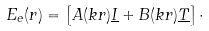Convert formula to latex. <formula><loc_0><loc_0><loc_500><loc_500>E _ { e } ( r ) = \left [ A ( k r ) \underline { I } + B ( k r ) \underline { T } \right ] \cdot</formula> 